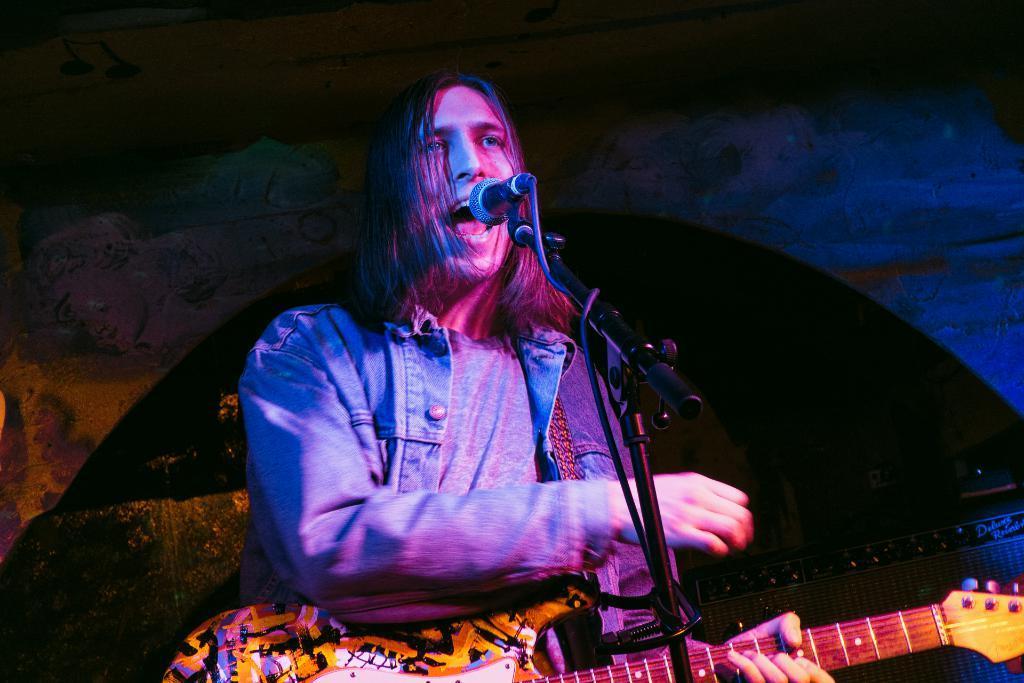Can you describe this image briefly? In this image we can see a person standing and holding a guitar. There is a mic placed on the stand. In the background there is a board. 